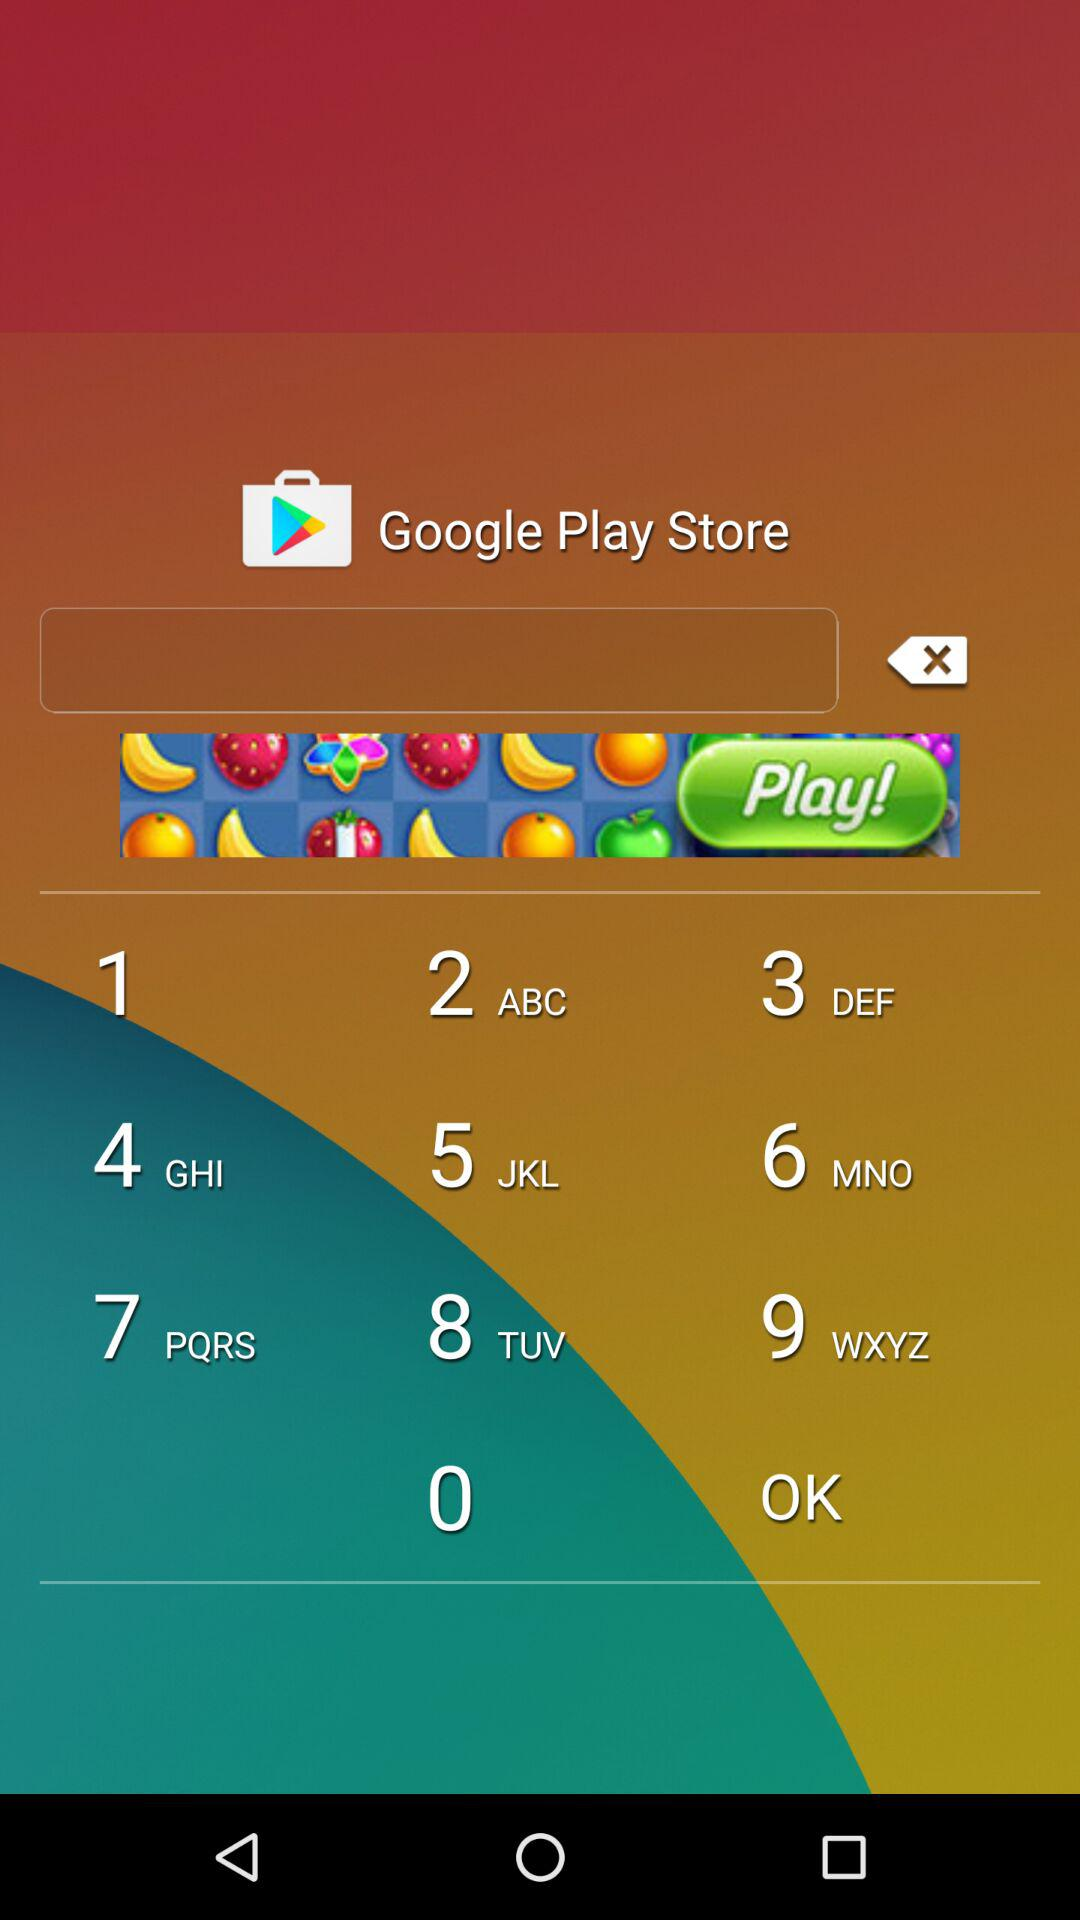What is the estimated due date? The estimated due date is December 22, 2017. 